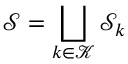Convert formula to latex. <formula><loc_0><loc_0><loc_500><loc_500>\mathcal { S } = \bigsqcup _ { k \in \mathcal { K } } \mathcal { S } _ { k }</formula> 